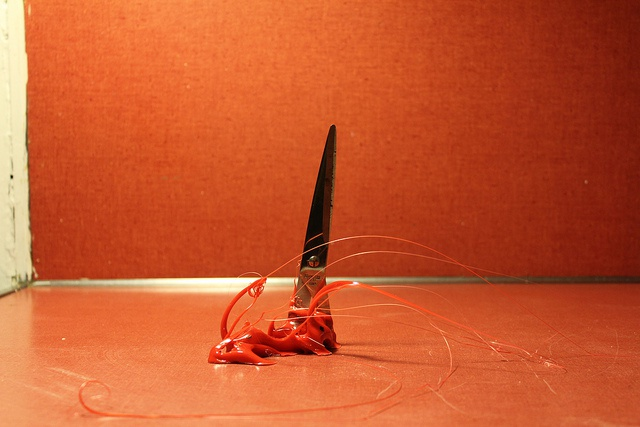Describe the objects in this image and their specific colors. I can see scissors in lightyellow, black, maroon, and brown tones in this image. 